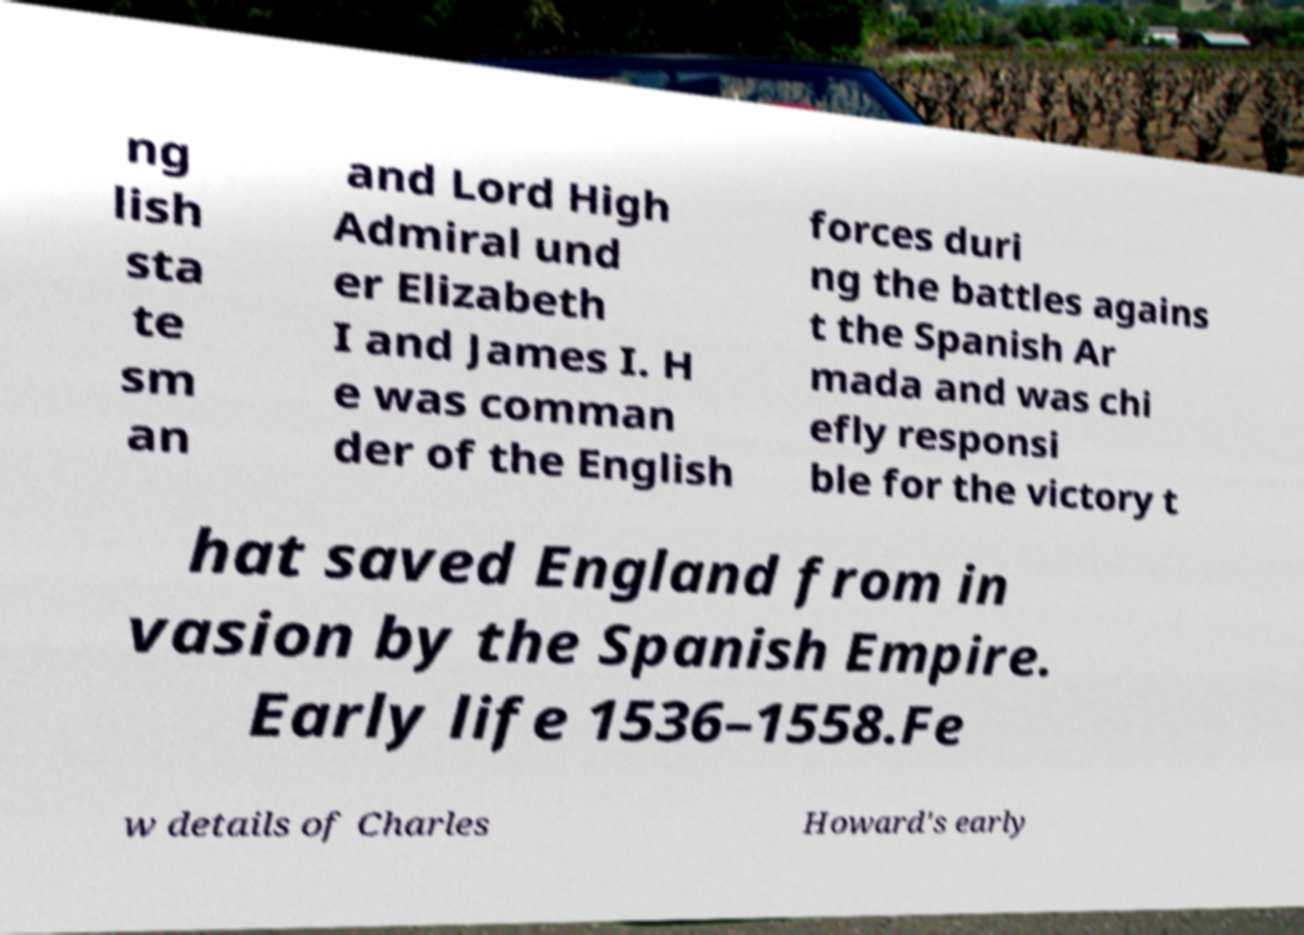Could you assist in decoding the text presented in this image and type it out clearly? ng lish sta te sm an and Lord High Admiral und er Elizabeth I and James I. H e was comman der of the English forces duri ng the battles agains t the Spanish Ar mada and was chi efly responsi ble for the victory t hat saved England from in vasion by the Spanish Empire. Early life 1536–1558.Fe w details of Charles Howard's early 